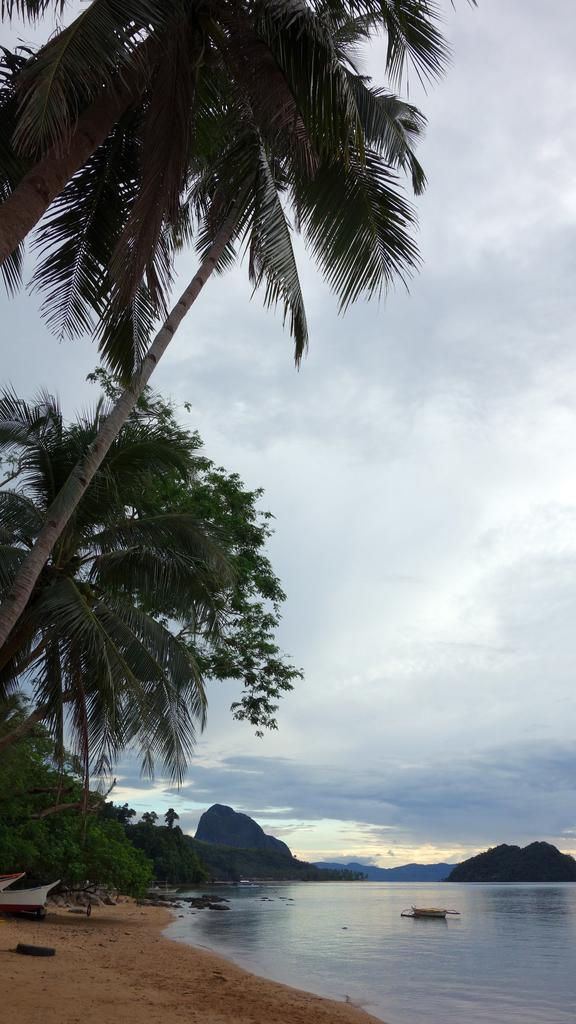What can be seen on the right side of the image? There is water on the right side of the image. What is located on the left side of the image? There are trees and boats on the left side of the image. What is visible in the background of the image? There are clouds and the sky visible in the background. What position does the history book hold in the image? There is no history book present in the image. What day of the week is depicted in the image? The day of the week is not mentioned or depicted in the image. 